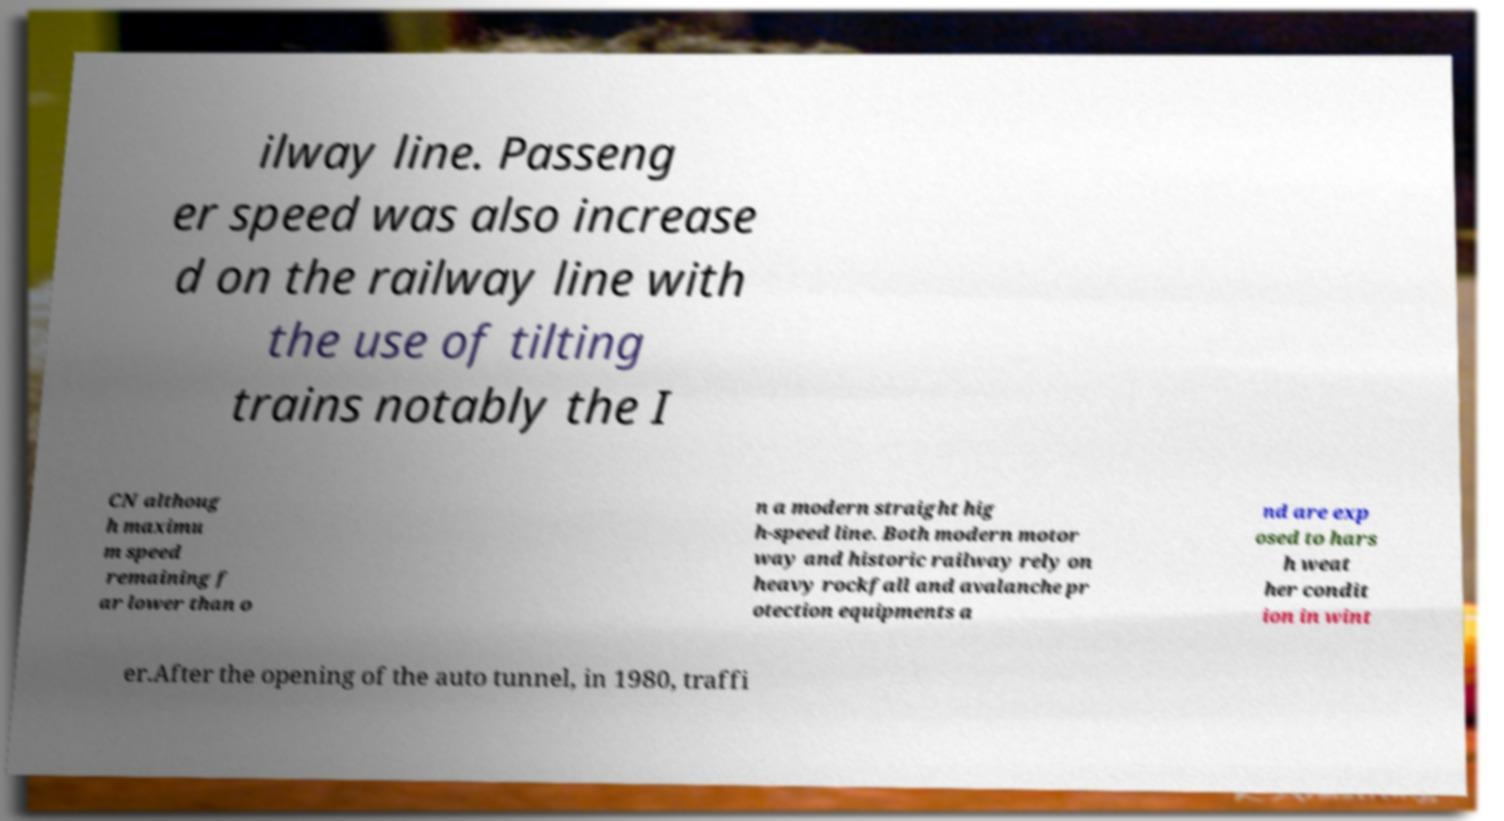What messages or text are displayed in this image? I need them in a readable, typed format. ilway line. Passeng er speed was also increase d on the railway line with the use of tilting trains notably the I CN althoug h maximu m speed remaining f ar lower than o n a modern straight hig h-speed line. Both modern motor way and historic railway rely on heavy rockfall and avalanche pr otection equipments a nd are exp osed to hars h weat her condit ion in wint er.After the opening of the auto tunnel, in 1980, traffi 